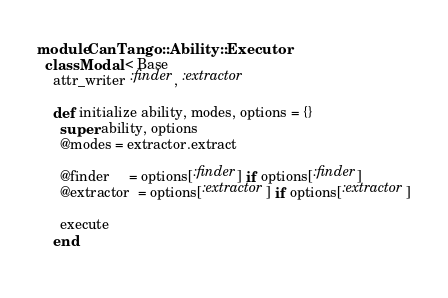<code> <loc_0><loc_0><loc_500><loc_500><_Ruby_>module CanTango::Ability::Executor
  class Modal < Base
    attr_writer :finder, :extractor

    def initialize ability, modes, options = {}
      super ability, options
      @modes = extractor.extract

      @finder     = options[:finder] if options[:finder]
      @extractor  = options[:extractor] if options[:extractor]

      execute
    end
    </code> 